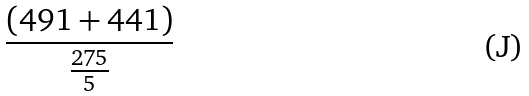Convert formula to latex. <formula><loc_0><loc_0><loc_500><loc_500>\frac { ( 4 9 1 + 4 4 1 ) } { \frac { 2 7 5 } { 5 } }</formula> 